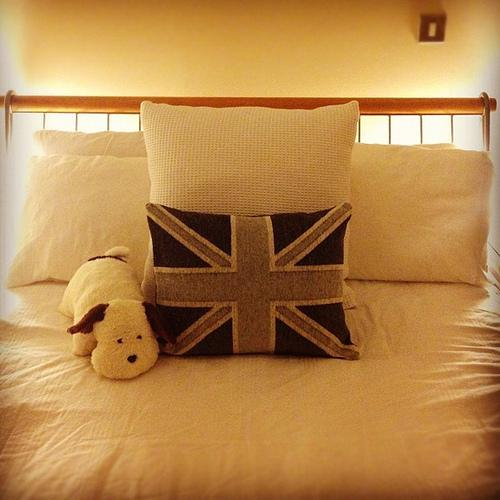Question: what is the photo of?
Choices:
A. A scary clown.
B. A cat.
C. The wrecked car.
D. A bed.
Answer with the letter. Answer: D Question: how many stuffed animals are there?
Choices:
A. One.
B. Two.
C. Three.
D. Four.
Answer with the letter. Answer: A Question: what flag is on pillow?
Choices:
A. British flag.
B. American.
C. Girl Scouts.
D. Dixie.
Answer with the letter. Answer: A 